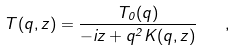<formula> <loc_0><loc_0><loc_500><loc_500>T ( q , z ) = \frac { T _ { 0 } ( q ) } { - i z + q ^ { 2 } K ( q , z ) } \quad ,</formula> 